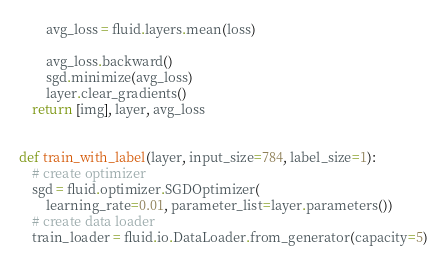Convert code to text. <code><loc_0><loc_0><loc_500><loc_500><_Python_>        avg_loss = fluid.layers.mean(loss)

        avg_loss.backward()
        sgd.minimize(avg_loss)
        layer.clear_gradients()
    return [img], layer, avg_loss


def train_with_label(layer, input_size=784, label_size=1):
    # create optimizer
    sgd = fluid.optimizer.SGDOptimizer(
        learning_rate=0.01, parameter_list=layer.parameters())
    # create data loader
    train_loader = fluid.io.DataLoader.from_generator(capacity=5)</code> 